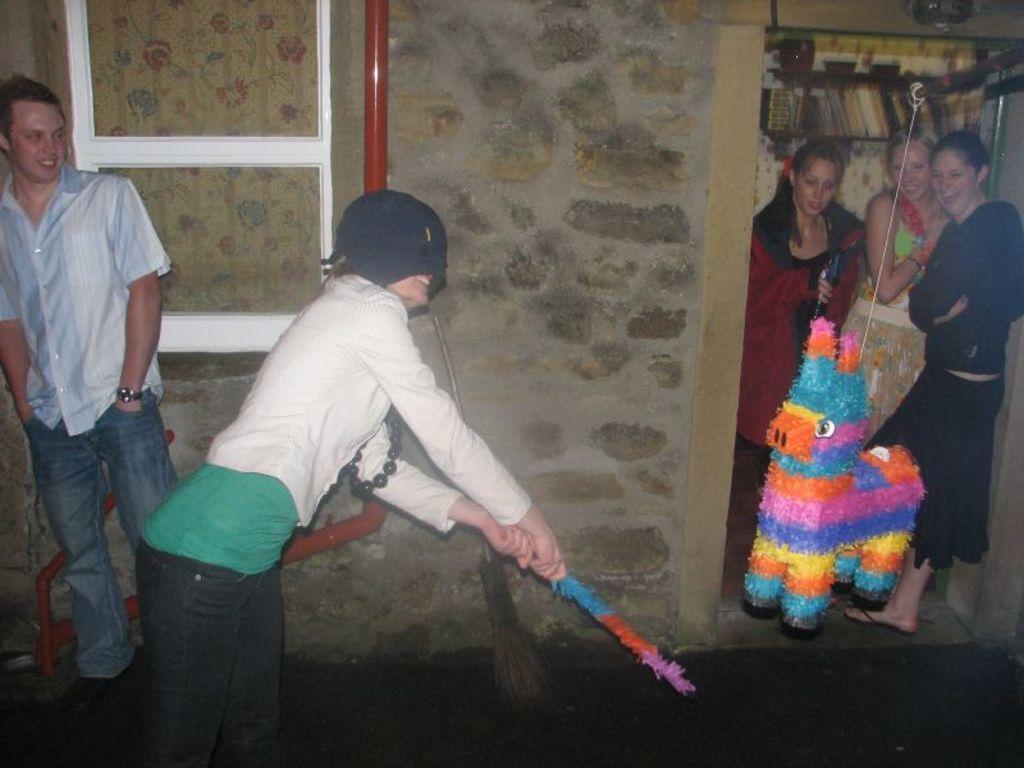Could you give a brief overview of what you see in this image? In this image there are persons standing and smiling, there is a wall and on the wall there is a pipe which is red in colour. On the right side in the background there are books in the shelf and there is a colourful object in front of the women and there is broom in front of the wall. In the front there is a person standing and holding colourful object in hand and smiling. 